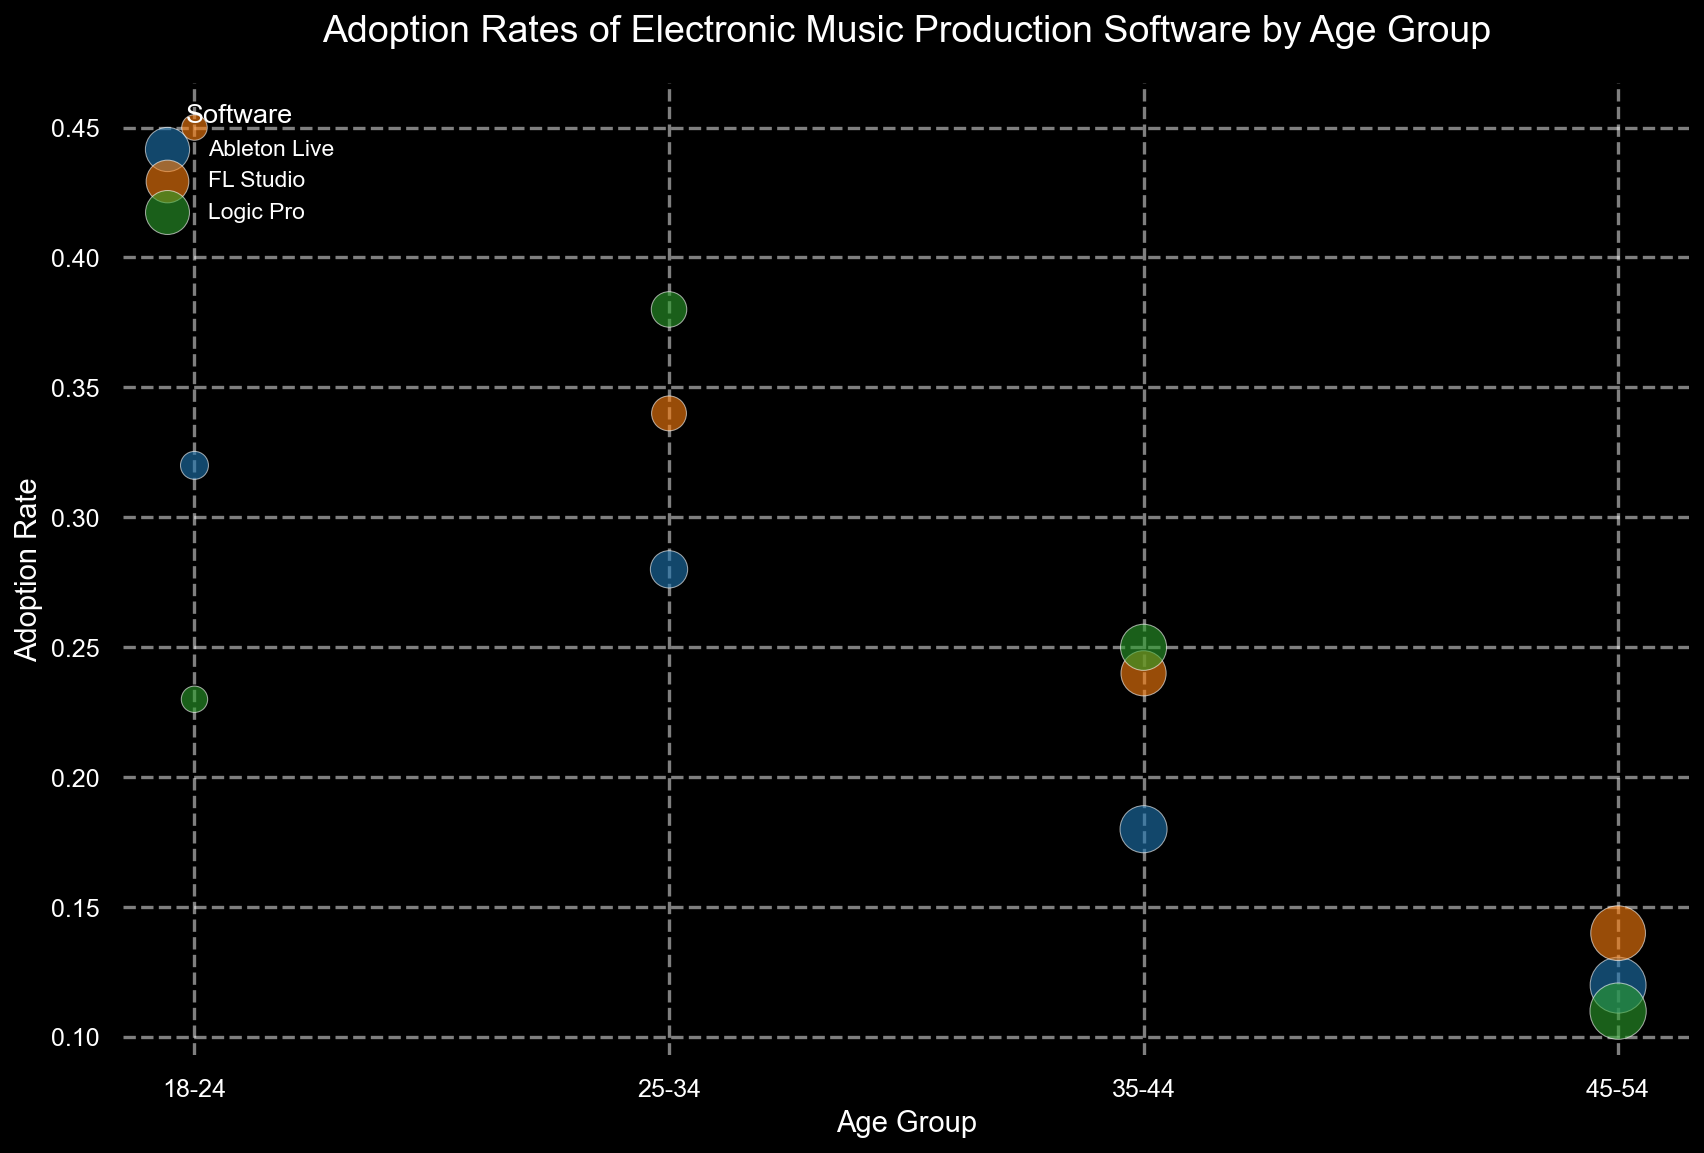Which age group has the highest adoption rate for FL Studio? By looking at the height of the bubbles for FL Studio, we see that the 18-24 age group has the highest adoption rate compared to the other age groups.
Answer: 18-24 What is the average adoption rate of Ableton Live across all age groups? Add the adoption rates of Ableton Live for all age groups: 0.32 (18-24), 0.28 (25-34), 0.18 (35-44), 0.12 (45-54). The sum is 0.90. Divide by the number of age groups (4) to get the average: 0.90 / 4 = 0.225.
Answer: 0.225 Which software has the smallest bubble in the 45-54 age group? The size of the bubbles represents the average years of experience. In the 45-54 age group, Logic Pro has the smallest bubble, indicating the least average years of experience.
Answer: Logic Pro Compare the adoption rates of Logic Pro between the 18-24 and 25-34 age groups. Which is higher? By checking the heights of the bubbles for Logic Pro, the adoption rate in the 25-34 age group (0.38) is higher than in the 18-24 age group (0.23).
Answer: 25-34 What is the combined adoption rate for all software in the 25-34 age group? Add the adoption rates for all software in the 25-34 age group: 0.28 (Ableton Live), 0.34 (FL Studio), 0.38 (Logic Pro). The sum is 0.28 + 0.34 + 0.38 = 1.00.
Answer: 1.00 Which age group has the largest bubbles, and what does that indicate? The size of the bubbles represents the average years of experience. The largest bubbles appear in the 45-54 age group, indicating the greatest average years of experience with electronic music production software.
Answer: 45-54 How does the adoption rate of FL Studio in the 35-44 age group compare to its adoption rate in the 25-34 age group? The adoption rate for FL Studio in the 35-44 age group is 0.24, whereas in the 25-34 age group it is 0.34. The 25-34 age group has a higher adoption rate.
Answer: 25-34 What is the difference in average years of experience for Ableton Live users between the 18-24 and 45-54 age groups? The average years of experience for Ableton Live users in the 18-24 age group is 1.8 years, and for the 45-54 age group, it is 7.2 years. The difference is 7.2 - 1.8 = 5.4 years.
Answer: 5.4 years Which software is the most popular among the 18-24 age group? By comparing the heights of the bubbles, FL Studio has the highest adoption rate among the 18-24 age group.
Answer: FL Studio 